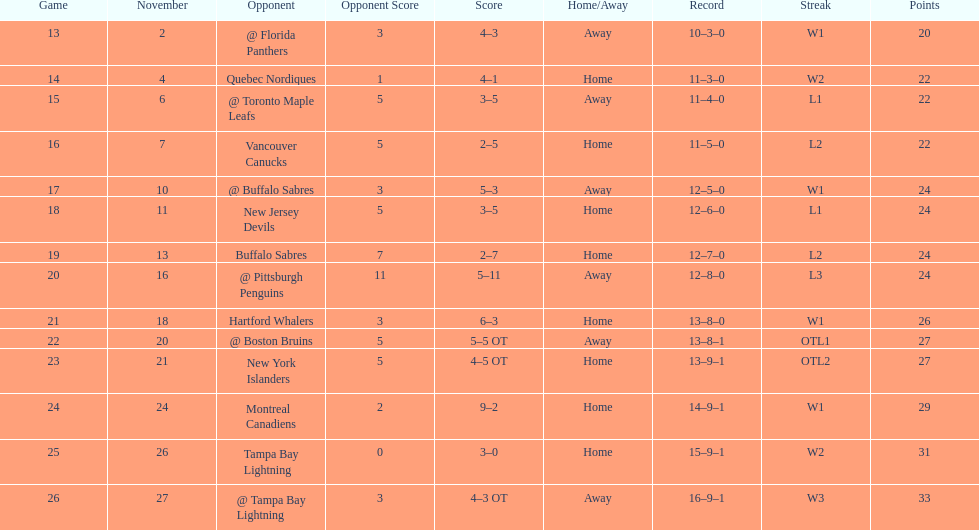What other team had the closest amount of wins? New York Islanders. 